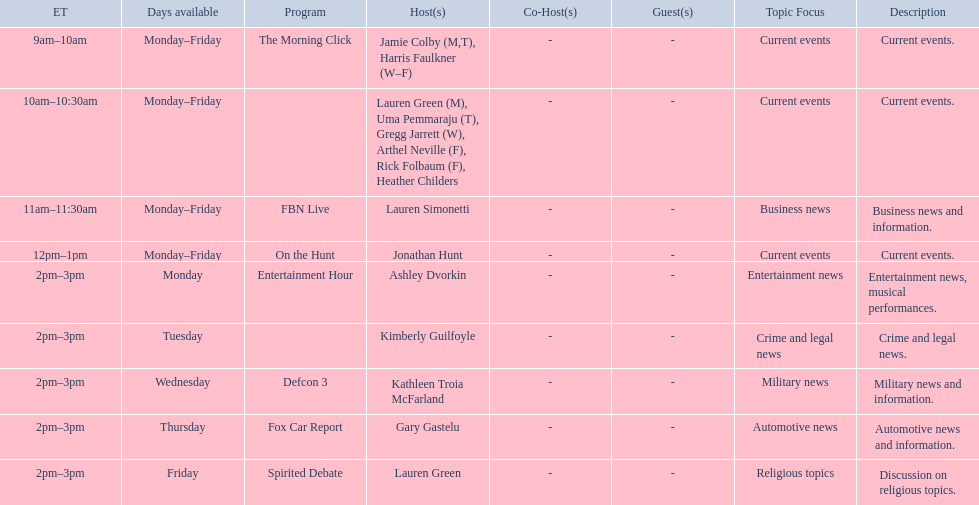Who are all of the hosts? Jamie Colby (M,T), Harris Faulkner (W–F), Lauren Green (M), Uma Pemmaraju (T), Gregg Jarrett (W), Arthel Neville (F), Rick Folbaum (F), Heather Childers, Lauren Simonetti, Jonathan Hunt, Ashley Dvorkin, Kimberly Guilfoyle, Kathleen Troia McFarland, Gary Gastelu, Lauren Green. Which hosts have shows on fridays? Jamie Colby (M,T), Harris Faulkner (W–F), Lauren Green (M), Uma Pemmaraju (T), Gregg Jarrett (W), Arthel Neville (F), Rick Folbaum (F), Heather Childers, Lauren Simonetti, Jonathan Hunt, Lauren Green. Of those, which host's show airs at 2pm? Lauren Green. 